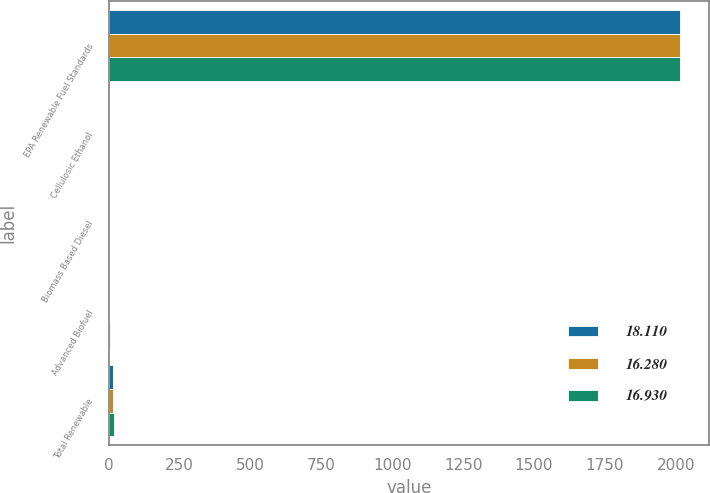<chart> <loc_0><loc_0><loc_500><loc_500><stacked_bar_chart><ecel><fcel>EPA Renewable Fuel Standards<fcel>Cellulosic Ethanol<fcel>Biomass Based Diesel<fcel>Advanced Biofuel<fcel>Total Renewable<nl><fcel>18.11<fcel>2014<fcel>0.03<fcel>1.63<fcel>2.67<fcel>16.28<nl><fcel>16.28<fcel>2015<fcel>0.12<fcel>1.73<fcel>2.88<fcel>16.93<nl><fcel>16.93<fcel>2016<fcel>0.23<fcel>1.9<fcel>3.61<fcel>18.11<nl></chart> 